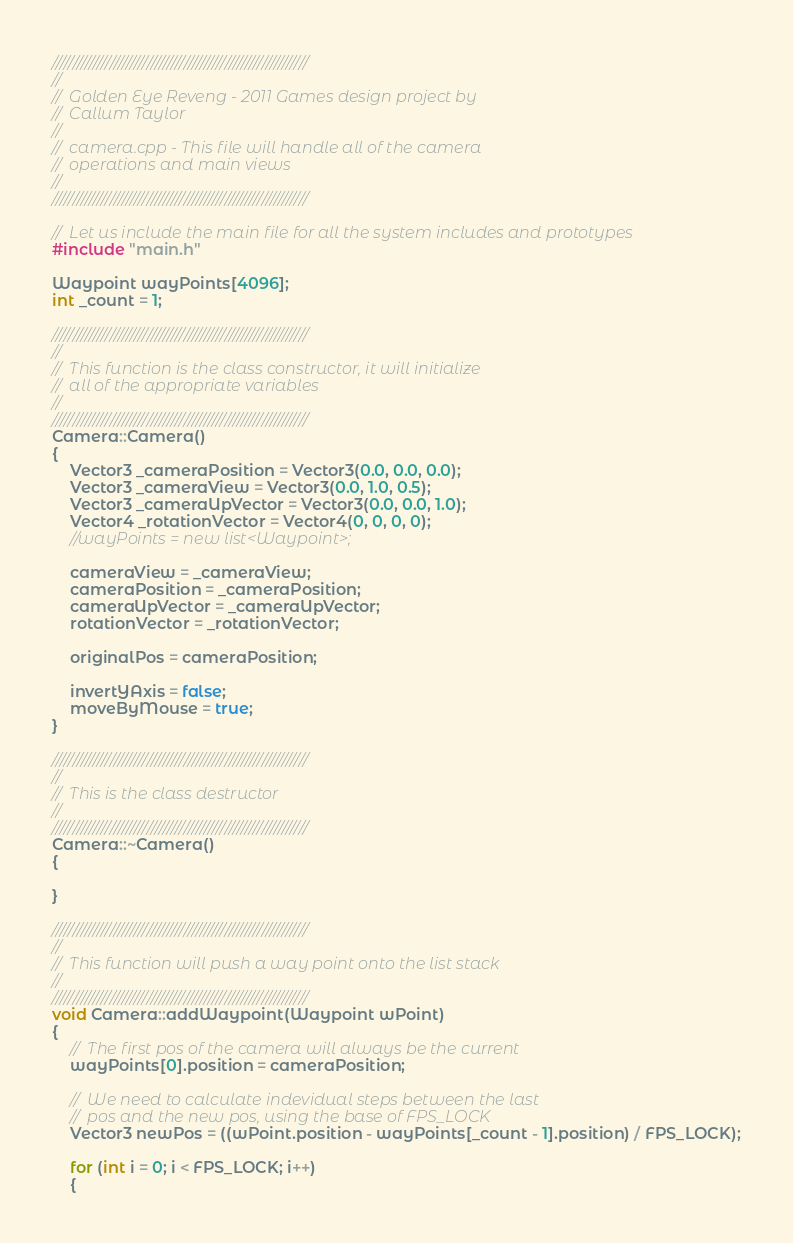<code> <loc_0><loc_0><loc_500><loc_500><_C++_>//////////////////////////////////////////////////////////////
//
//	Golden Eye Reveng - 2011 Games design project by
//	Callum Taylor
//
//	camera.cpp - This file will handle all of the camera 
//	operations and main views
//
//////////////////////////////////////////////////////////////

//	Let us include the main file for all the system includes and prototypes
#include "main.h"

Waypoint wayPoints[4096];
int _count = 1;

//////////////////////////////////////////////////////////////
//
//	This function is the class constructor, it will initialize
//	all of the appropriate variables
//
//////////////////////////////////////////////////////////////
Camera::Camera()
{
	Vector3 _cameraPosition = Vector3(0.0, 0.0, 0.0);
	Vector3 _cameraView = Vector3(0.0, 1.0, 0.5);
	Vector3 _cameraUpVector = Vector3(0.0, 0.0, 1.0);
	Vector4 _rotationVector = Vector4(0, 0, 0, 0);
	//wayPoints = new list<Waypoint>;

	cameraView = _cameraView;
	cameraPosition = _cameraPosition;
	cameraUpVector = _cameraUpVector;
	rotationVector = _rotationVector;

	originalPos = cameraPosition;

	invertYAxis = false;
	moveByMouse = true;
}

//////////////////////////////////////////////////////////////
//
//	This is the class destructor
//
//////////////////////////////////////////////////////////////
Camera::~Camera()
{

}

//////////////////////////////////////////////////////////////
//
//	This function will push a way point onto the list stack
//
//////////////////////////////////////////////////////////////
void Camera::addWaypoint(Waypoint wPoint)
{
	//	The first pos of the camera will always be the current
	wayPoints[0].position = cameraPosition;	

	//	We need to calculate indevidual steps between the last
	//	pos and the new pos, using the base of FPS_LOCK
	Vector3 newPos = ((wPoint.position - wayPoints[_count - 1].position) / FPS_LOCK);

	for (int i = 0; i < FPS_LOCK; i++)
	{</code> 